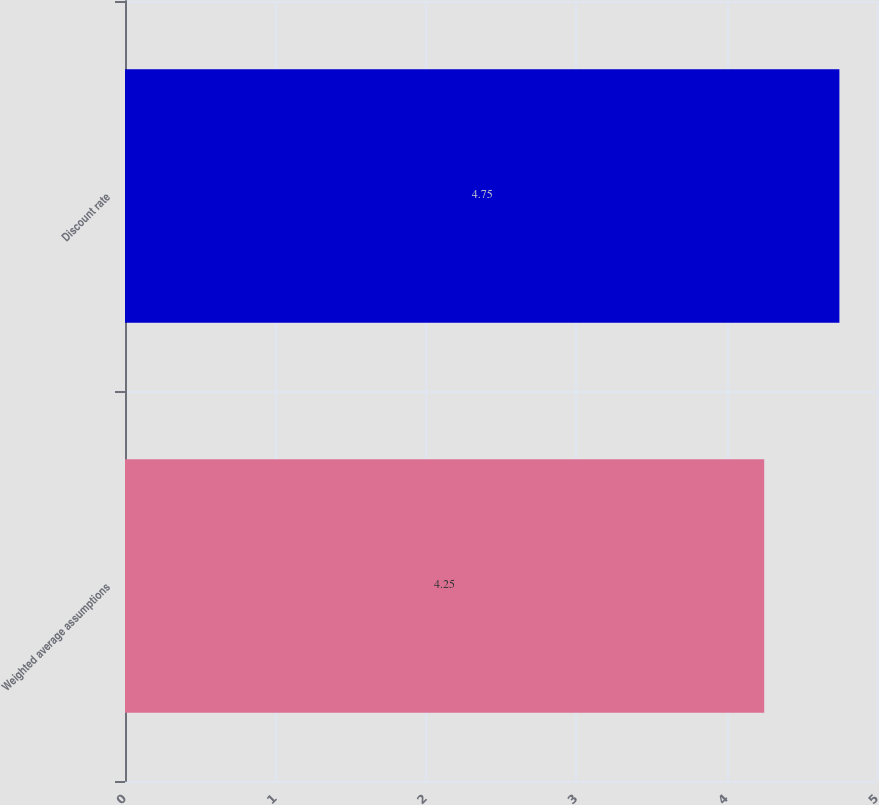Convert chart to OTSL. <chart><loc_0><loc_0><loc_500><loc_500><bar_chart><fcel>Weighted average assumptions<fcel>Discount rate<nl><fcel>4.25<fcel>4.75<nl></chart> 